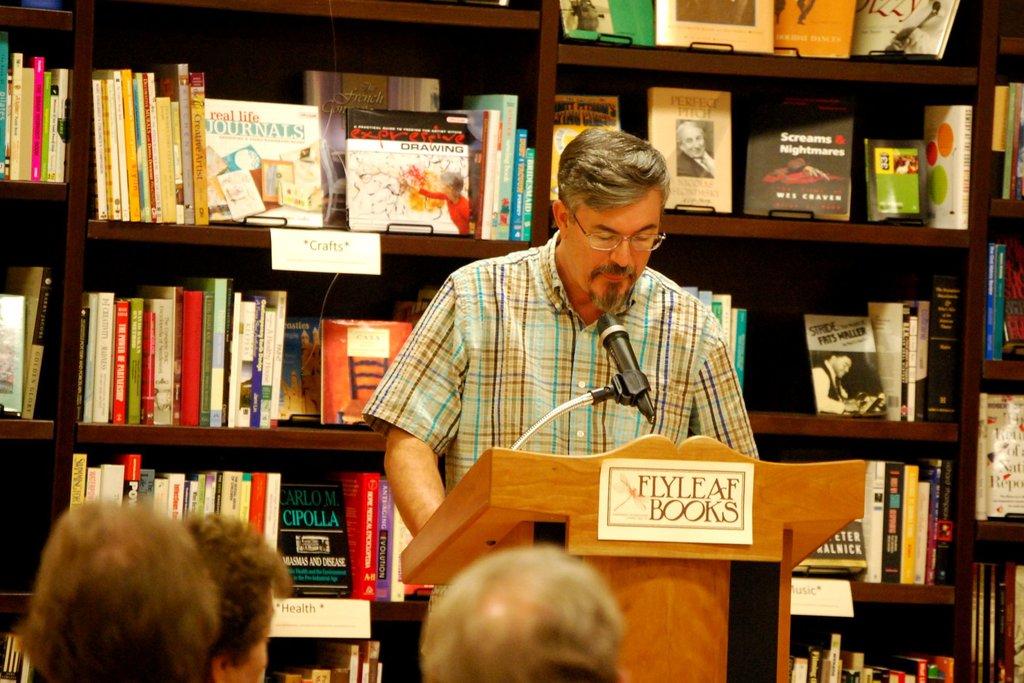What is the book brand name?
Give a very brief answer. Flyleaf books. What subject is on the top shelf behind the speaker?
Your response must be concise. Crafts. 